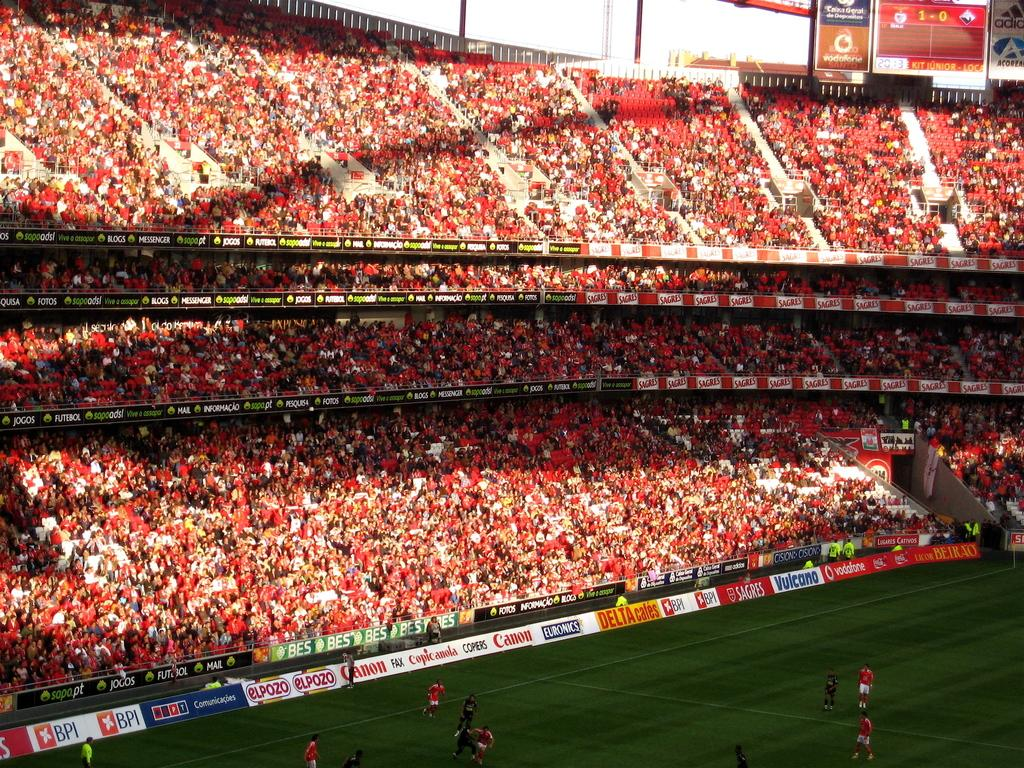Provide a one-sentence caption for the provided image. Canon is one of the sponsors of this large stadium with red seats. 